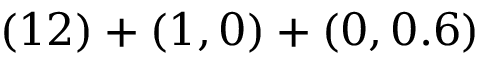Convert formula to latex. <formula><loc_0><loc_0><loc_500><loc_500>( 1 2 ) + ( 1 , 0 ) + ( 0 , 0 . 6 )</formula> 